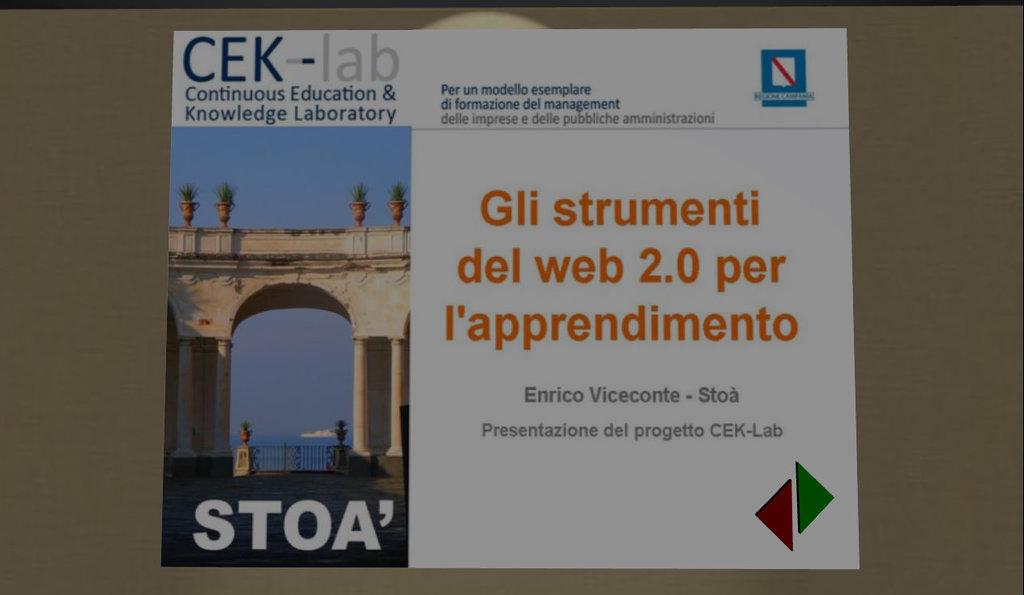What is the name of the laboratory?
Your response must be concise. Cek-lab. 